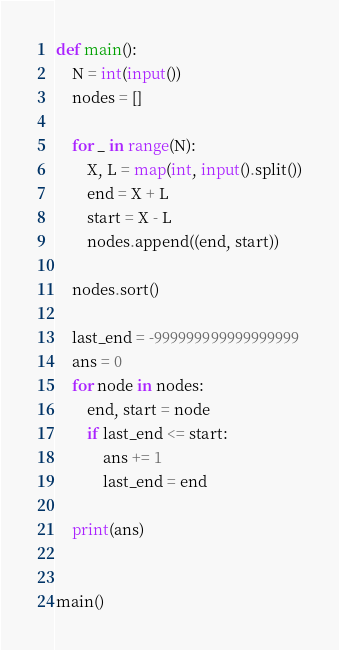Convert code to text. <code><loc_0><loc_0><loc_500><loc_500><_Python_>def main():
    N = int(input())
    nodes = []

    for _ in range(N):
        X, L = map(int, input().split())
        end = X + L
        start = X - L
        nodes.append((end, start))

    nodes.sort()

    last_end = -999999999999999999
    ans = 0
    for node in nodes:
        end, start = node
        if last_end <= start:
            ans += 1
            last_end = end

    print(ans)


main()
</code> 